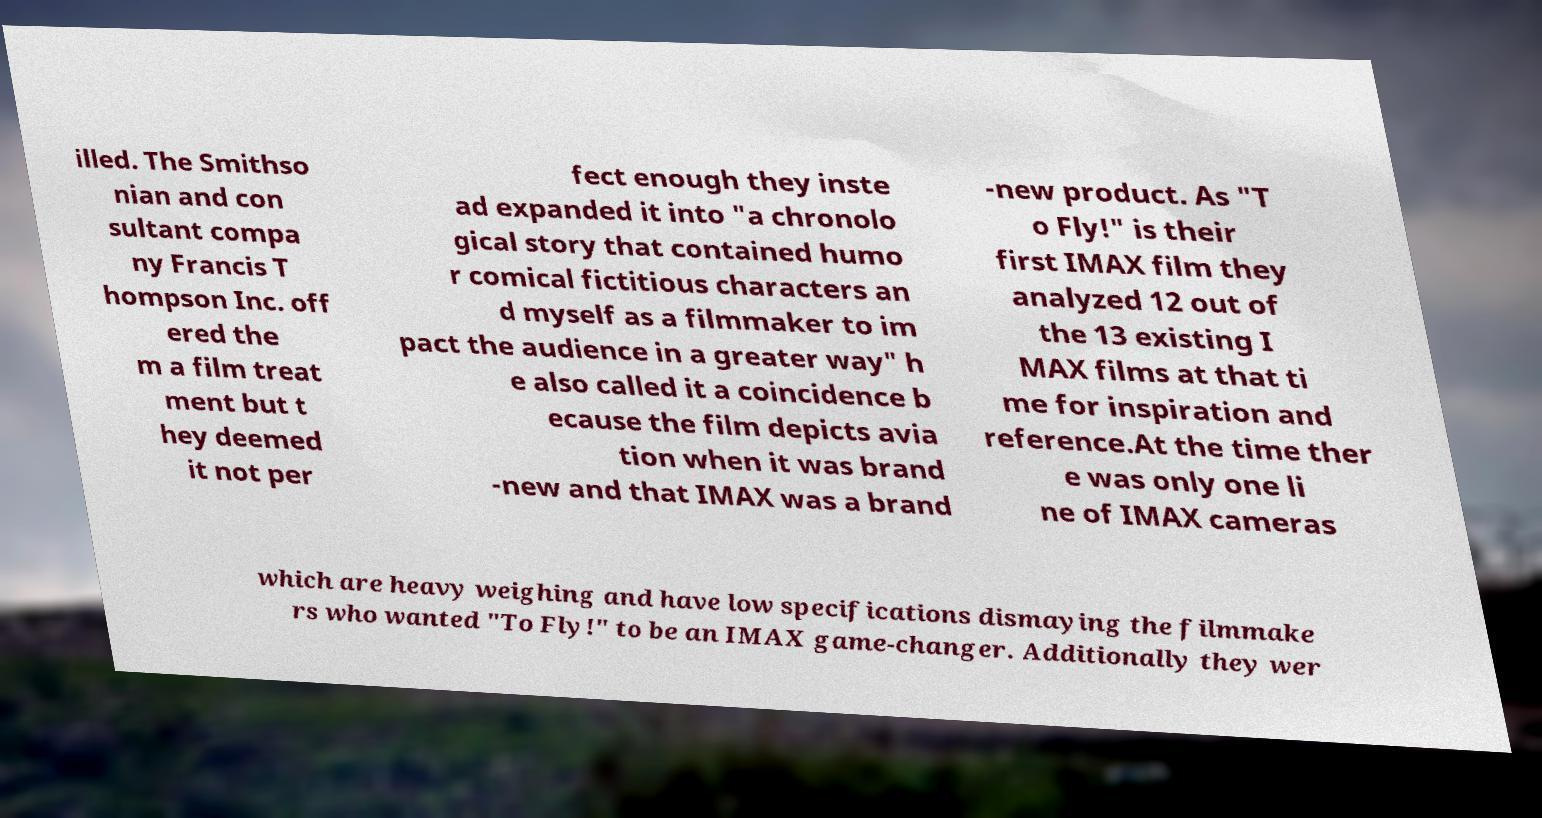Please read and relay the text visible in this image. What does it say? illed. The Smithso nian and con sultant compa ny Francis T hompson Inc. off ered the m a film treat ment but t hey deemed it not per fect enough they inste ad expanded it into "a chronolo gical story that contained humo r comical fictitious characters an d myself as a filmmaker to im pact the audience in a greater way" h e also called it a coincidence b ecause the film depicts avia tion when it was brand -new and that IMAX was a brand -new product. As "T o Fly!" is their first IMAX film they analyzed 12 out of the 13 existing I MAX films at that ti me for inspiration and reference.At the time ther e was only one li ne of IMAX cameras which are heavy weighing and have low specifications dismaying the filmmake rs who wanted "To Fly!" to be an IMAX game-changer. Additionally they wer 